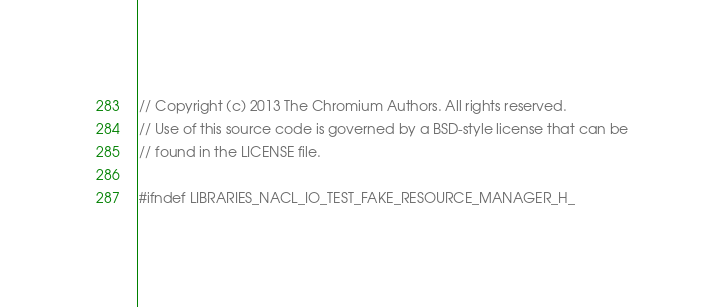Convert code to text. <code><loc_0><loc_0><loc_500><loc_500><_C_>// Copyright (c) 2013 The Chromium Authors. All rights reserved.
// Use of this source code is governed by a BSD-style license that can be
// found in the LICENSE file.

#ifndef LIBRARIES_NACL_IO_TEST_FAKE_RESOURCE_MANAGER_H_</code> 